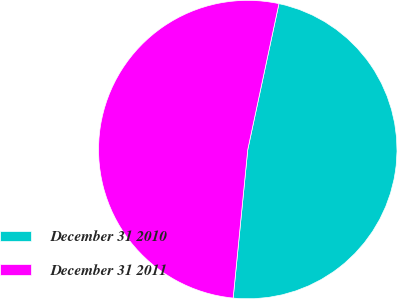Convert chart. <chart><loc_0><loc_0><loc_500><loc_500><pie_chart><fcel>December 31 2010<fcel>December 31 2011<nl><fcel>48.21%<fcel>51.79%<nl></chart> 